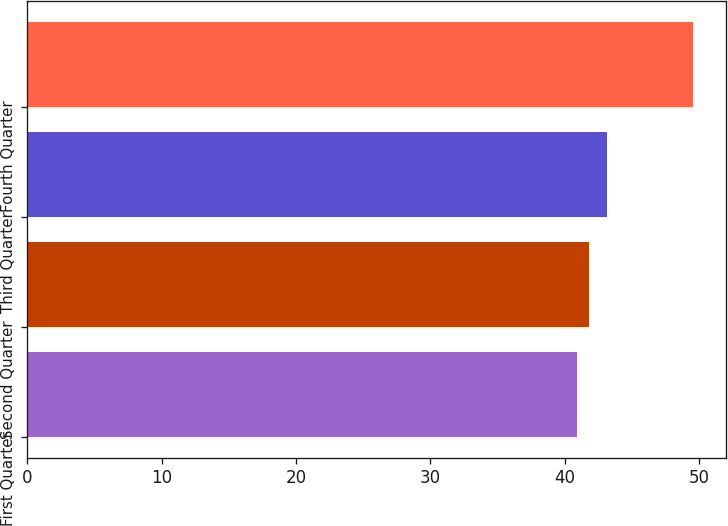Convert chart. <chart><loc_0><loc_0><loc_500><loc_500><bar_chart><fcel>First Quarter<fcel>Second Quarter<fcel>Third Quarter<fcel>Fourth Quarter<nl><fcel>40.92<fcel>41.83<fcel>43.11<fcel>49.52<nl></chart> 